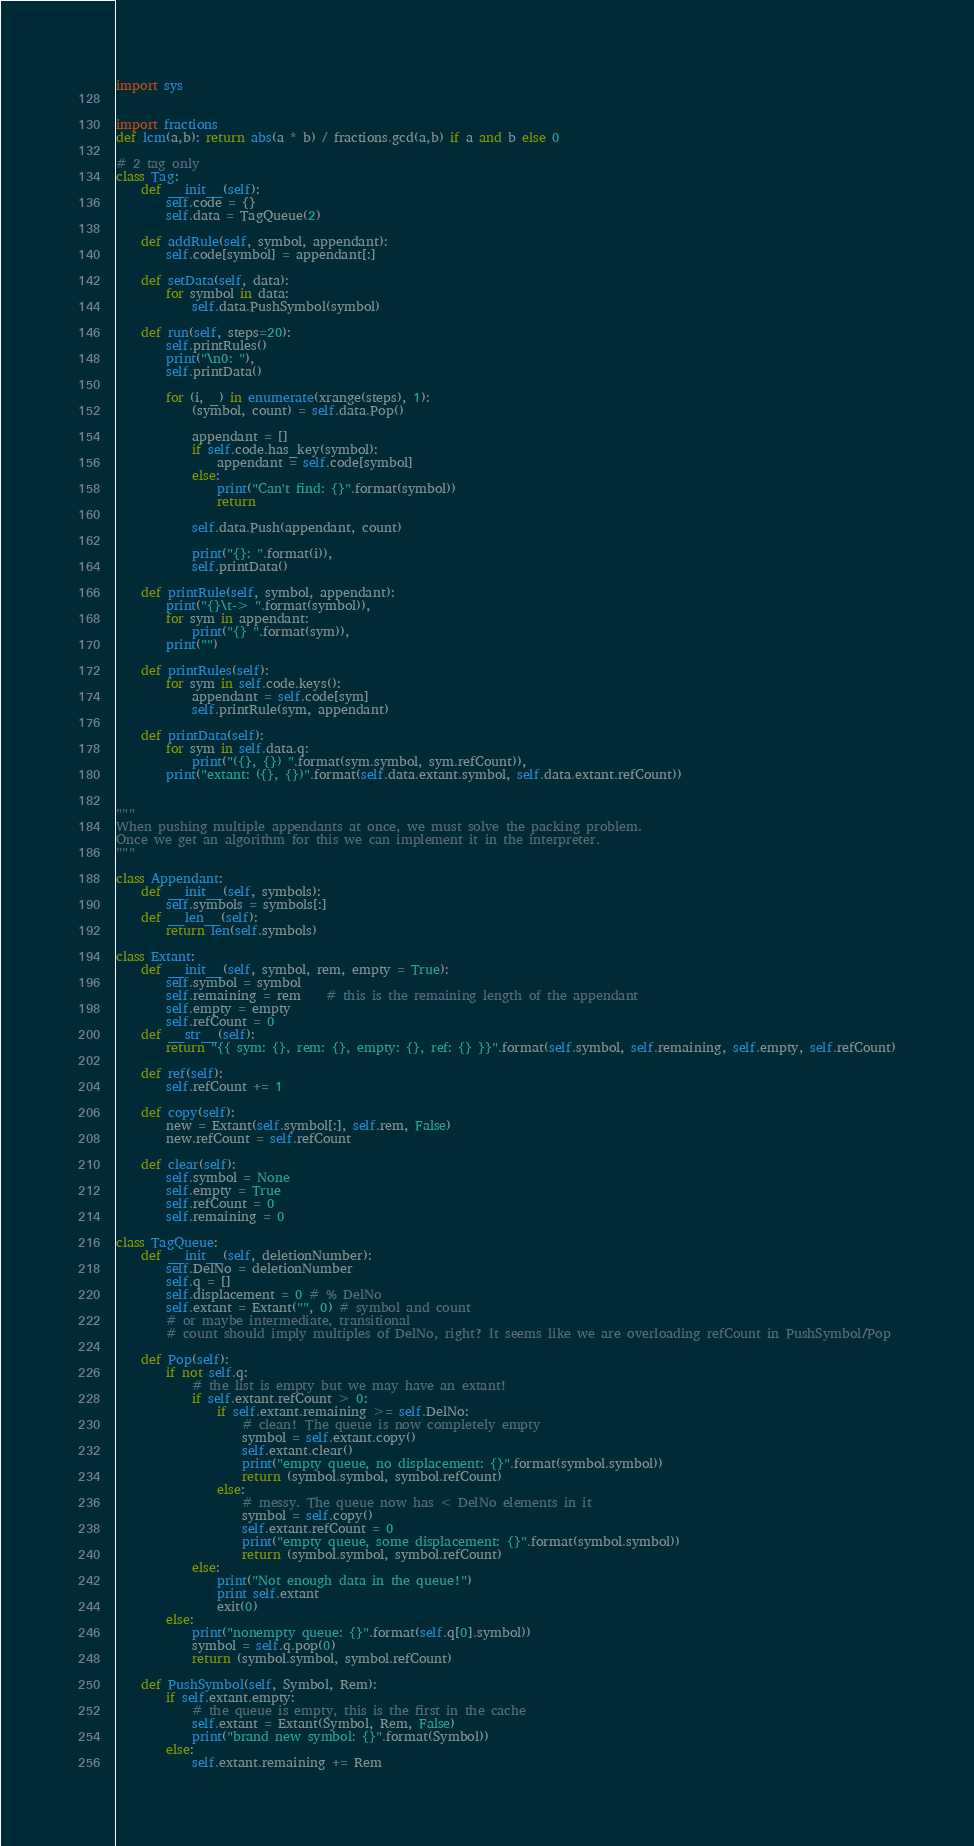Convert code to text. <code><loc_0><loc_0><loc_500><loc_500><_Python_>import sys


import fractions
def lcm(a,b): return abs(a * b) / fractions.gcd(a,b) if a and b else 0

# 2 tag only
class Tag:
    def __init__(self):
        self.code = {}
        self.data = TagQueue(2)

    def addRule(self, symbol, appendant):
        self.code[symbol] = appendant[:]

    def setData(self, data):
        for symbol in data:
            self.data.PushSymbol(symbol)

    def run(self, steps=20):
        self.printRules()
        print("\n0: "),
        self.printData()

        for (i, _) in enumerate(xrange(steps), 1):
            (symbol, count) = self.data.Pop()

            appendant = []
            if self.code.has_key(symbol):
                appendant = self.code[symbol]
            else:
                print("Can't find: {}".format(symbol))
                return

            self.data.Push(appendant, count)

            print("{}: ".format(i)),
            self.printData()

    def printRule(self, symbol, appendant):
        print("{}\t-> ".format(symbol)),
        for sym in appendant:
            print("{} ".format(sym)),
        print("")

    def printRules(self):
        for sym in self.code.keys():
            appendant = self.code[sym]
            self.printRule(sym, appendant)

    def printData(self):
        for sym in self.data.q:
            print("({}, {}) ".format(sym.symbol, sym.refCount)),
        print("extant: ({}, {})".format(self.data.extant.symbol, self.data.extant.refCount))


"""
When pushing multiple appendants at once, we must solve the packing problem.
Once we get an algorithm for this we can implement it in the interpreter.
"""

class Appendant:
    def __init__(self, symbols):
        self.symbols = symbols[:]
    def __len__(self):
        return len(self.symbols)

class Extant:
    def __init__(self, symbol, rem, empty = True):
        self.symbol = symbol
        self.remaining = rem	# this is the remaining length of the appendant
        self.empty = empty
        self.refCount = 0
    def __str__(self):
        return "{{ sym: {}, rem: {}, empty: {}, ref: {} }}".format(self.symbol, self.remaining, self.empty, self.refCount)

    def ref(self):
        self.refCount += 1

    def copy(self):
        new = Extant(self.symbol[:], self.rem, False)
        new.refCount = self.refCount

    def clear(self):
        self.symbol = None
        self.empty = True
        self.refCount = 0
        self.remaining = 0

class TagQueue:
    def __init__(self, deletionNumber):
        self.DelNo = deletionNumber
        self.q = []
        self.displacement = 0 # % DelNo
        self.extant = Extant("", 0) # symbol and count
        # or maybe intermediate, transitional
        # count should imply multiples of DelNo, right? It seems like we are overloading refCount in PushSymbol/Pop

    def Pop(self):
        if not self.q:
            # the list is empty but we may have an extant!
            if self.extant.refCount > 0:
                if self.extant.remaining >= self.DelNo:
                    # clean! The queue is now completely empty
                    symbol = self.extant.copy()
                    self.extant.clear()
                    print("empty queue, no displacement: {}".format(symbol.symbol))
                    return (symbol.symbol, symbol.refCount)
                else:
                    # messy. The queue now has < DelNo elements in it
                    symbol = self.copy()
                    self.extant.refCount = 0
                    print("empty queue, some displacement: {}".format(symbol.symbol))
                    return (symbol.symbol, symbol.refCount)
            else:
                print("Not enough data in the queue!")
                print self.extant
                exit(0)
        else:
            print("nonempty queue: {}".format(self.q[0].symbol))
            symbol = self.q.pop(0)
            return (symbol.symbol, symbol.refCount)

    def PushSymbol(self, Symbol, Rem):
        if self.extant.empty:
            # the queue is empty, this is the first in the cache
            self.extant = Extant(Symbol, Rem, False)
            print("brand new symbol: {}".format(Symbol))
        else:
            self.extant.remaining += Rem</code> 